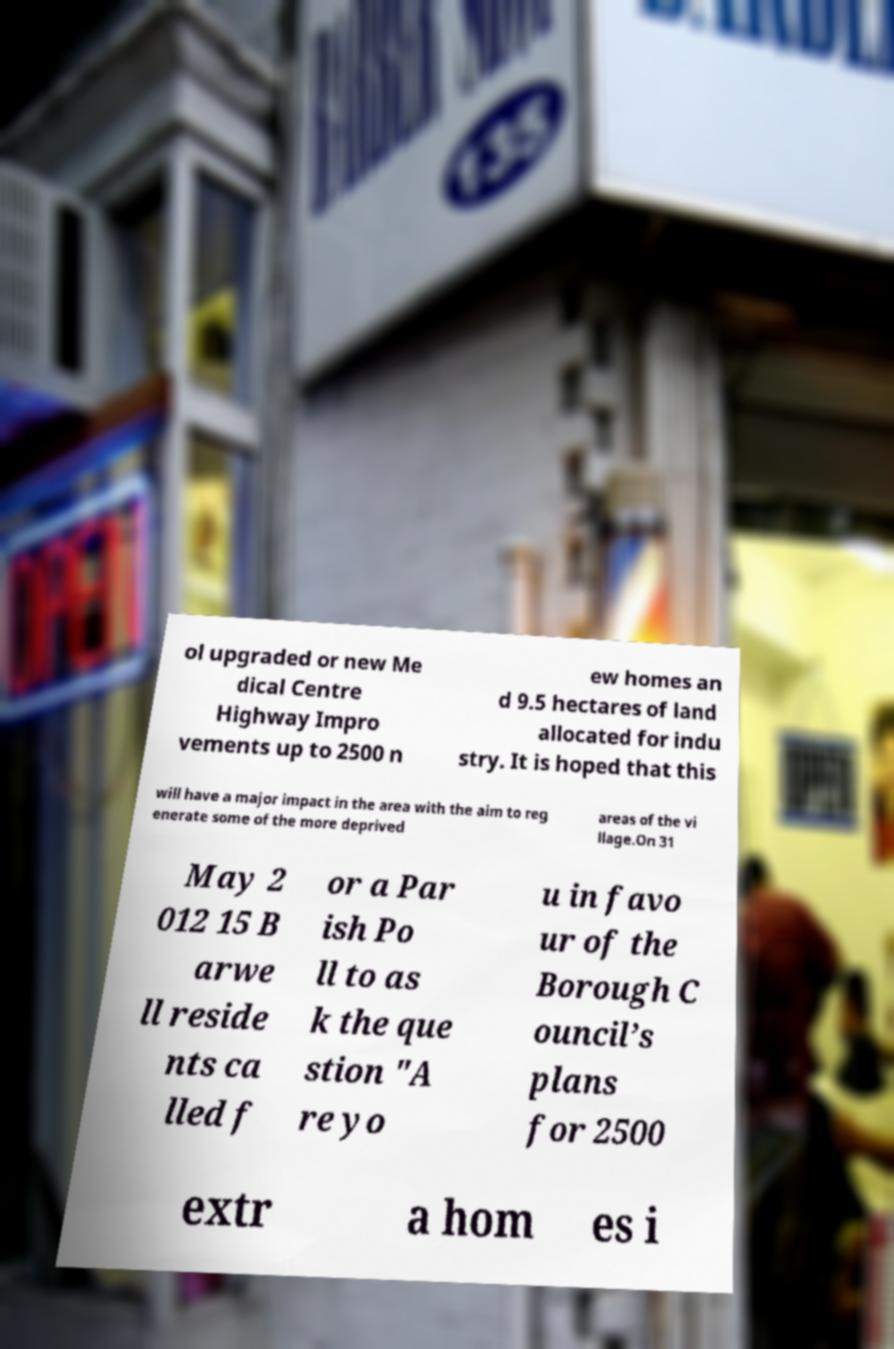Please read and relay the text visible in this image. What does it say? ol upgraded or new Me dical Centre Highway Impro vements up to 2500 n ew homes an d 9.5 hectares of land allocated for indu stry. It is hoped that this will have a major impact in the area with the aim to reg enerate some of the more deprived areas of the vi llage.On 31 May 2 012 15 B arwe ll reside nts ca lled f or a Par ish Po ll to as k the que stion "A re yo u in favo ur of the Borough C ouncil’s plans for 2500 extr a hom es i 